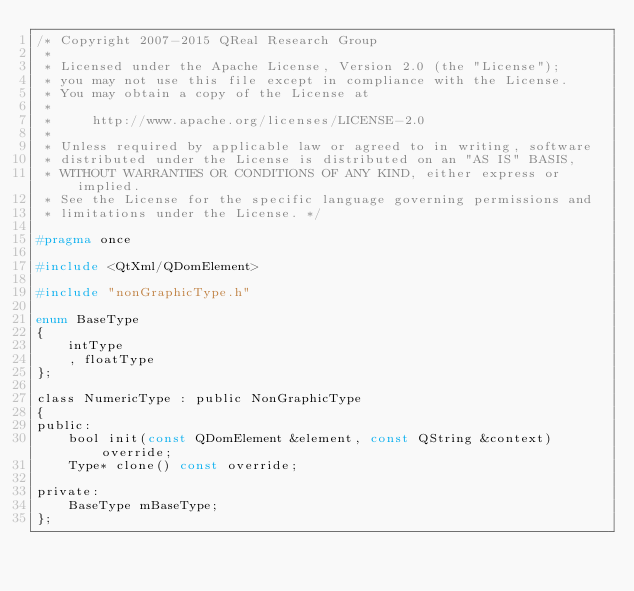Convert code to text. <code><loc_0><loc_0><loc_500><loc_500><_C_>/* Copyright 2007-2015 QReal Research Group
 *
 * Licensed under the Apache License, Version 2.0 (the "License");
 * you may not use this file except in compliance with the License.
 * You may obtain a copy of the License at
 *
 *     http://www.apache.org/licenses/LICENSE-2.0
 *
 * Unless required by applicable law or agreed to in writing, software
 * distributed under the License is distributed on an "AS IS" BASIS,
 * WITHOUT WARRANTIES OR CONDITIONS OF ANY KIND, either express or implied.
 * See the License for the specific language governing permissions and
 * limitations under the License. */

#pragma once

#include <QtXml/QDomElement>

#include "nonGraphicType.h"

enum BaseType
{
	intType
	, floatType
};

class NumericType : public NonGraphicType
{
public:
	bool init(const QDomElement &element, const QString &context) override;
	Type* clone() const override;

private:
	BaseType mBaseType;
};
</code> 